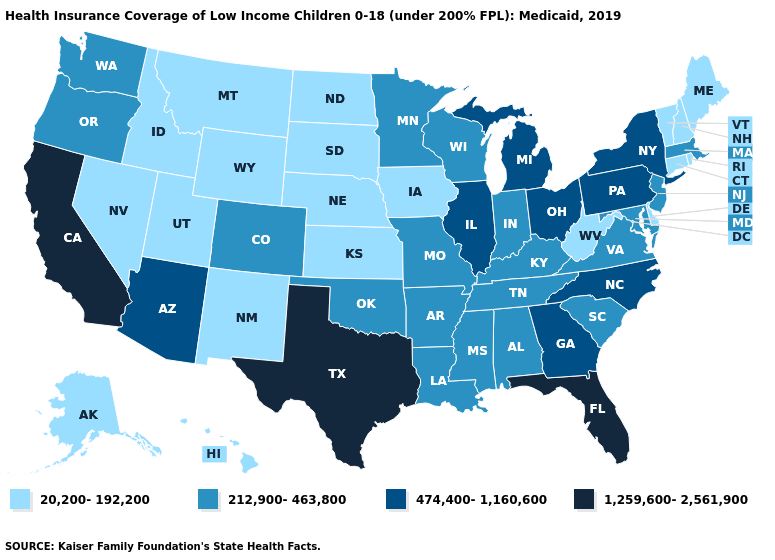Which states have the lowest value in the Northeast?
Concise answer only. Connecticut, Maine, New Hampshire, Rhode Island, Vermont. Among the states that border Nevada , which have the lowest value?
Short answer required. Idaho, Utah. What is the lowest value in states that border South Dakota?
Keep it brief. 20,200-192,200. Does Oregon have the same value as West Virginia?
Be succinct. No. Does Wyoming have the highest value in the USA?
Concise answer only. No. What is the lowest value in states that border New Hampshire?
Give a very brief answer. 20,200-192,200. Which states have the highest value in the USA?
Concise answer only. California, Florida, Texas. Does the map have missing data?
Concise answer only. No. Does Maine have the lowest value in the Northeast?
Write a very short answer. Yes. What is the value of Wyoming?
Write a very short answer. 20,200-192,200. What is the highest value in the USA?
Keep it brief. 1,259,600-2,561,900. Name the states that have a value in the range 212,900-463,800?
Give a very brief answer. Alabama, Arkansas, Colorado, Indiana, Kentucky, Louisiana, Maryland, Massachusetts, Minnesota, Mississippi, Missouri, New Jersey, Oklahoma, Oregon, South Carolina, Tennessee, Virginia, Washington, Wisconsin. Among the states that border South Dakota , does Minnesota have the highest value?
Keep it brief. Yes. Name the states that have a value in the range 20,200-192,200?
Keep it brief. Alaska, Connecticut, Delaware, Hawaii, Idaho, Iowa, Kansas, Maine, Montana, Nebraska, Nevada, New Hampshire, New Mexico, North Dakota, Rhode Island, South Dakota, Utah, Vermont, West Virginia, Wyoming. Name the states that have a value in the range 20,200-192,200?
Concise answer only. Alaska, Connecticut, Delaware, Hawaii, Idaho, Iowa, Kansas, Maine, Montana, Nebraska, Nevada, New Hampshire, New Mexico, North Dakota, Rhode Island, South Dakota, Utah, Vermont, West Virginia, Wyoming. 